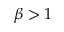Convert formula to latex. <formula><loc_0><loc_0><loc_500><loc_500>\beta > 1</formula> 